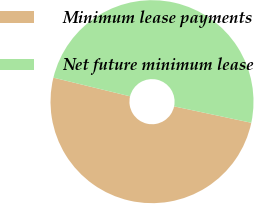<chart> <loc_0><loc_0><loc_500><loc_500><pie_chart><fcel>Minimum lease payments<fcel>Net future minimum lease<nl><fcel>50.47%<fcel>49.53%<nl></chart> 